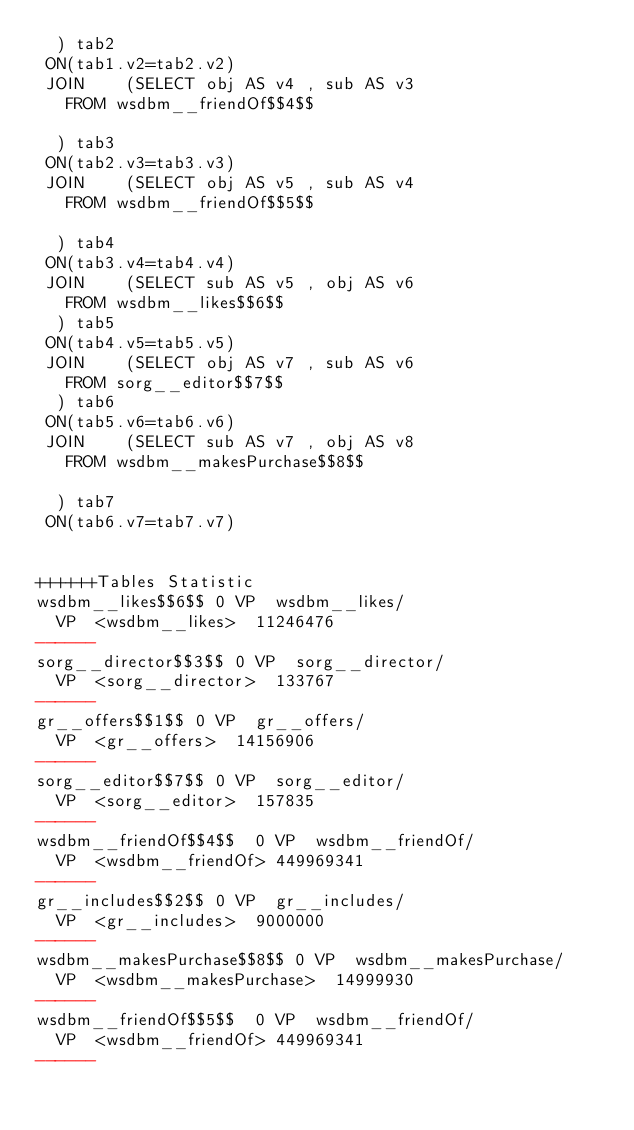Convert code to text. <code><loc_0><loc_0><loc_500><loc_500><_SQL_>	) tab2
 ON(tab1.v2=tab2.v2)
 JOIN    (SELECT obj AS v4 , sub AS v3 
	 FROM wsdbm__friendOf$$4$$
	
	) tab3
 ON(tab2.v3=tab3.v3)
 JOIN    (SELECT obj AS v5 , sub AS v4 
	 FROM wsdbm__friendOf$$5$$
	
	) tab4
 ON(tab3.v4=tab4.v4)
 JOIN    (SELECT sub AS v5 , obj AS v6 
	 FROM wsdbm__likes$$6$$
	) tab5
 ON(tab4.v5=tab5.v5)
 JOIN    (SELECT obj AS v7 , sub AS v6 
	 FROM sorg__editor$$7$$
	) tab6
 ON(tab5.v6=tab6.v6)
 JOIN    (SELECT sub AS v7 , obj AS v8 
	 FROM wsdbm__makesPurchase$$8$$
	
	) tab7
 ON(tab6.v7=tab7.v7)


++++++Tables Statistic
wsdbm__likes$$6$$	0	VP	wsdbm__likes/
	VP	<wsdbm__likes>	11246476
------
sorg__director$$3$$	0	VP	sorg__director/
	VP	<sorg__director>	133767
------
gr__offers$$1$$	0	VP	gr__offers/
	VP	<gr__offers>	14156906
------
sorg__editor$$7$$	0	VP	sorg__editor/
	VP	<sorg__editor>	157835
------
wsdbm__friendOf$$4$$	0	VP	wsdbm__friendOf/
	VP	<wsdbm__friendOf>	449969341
------
gr__includes$$2$$	0	VP	gr__includes/
	VP	<gr__includes>	9000000
------
wsdbm__makesPurchase$$8$$	0	VP	wsdbm__makesPurchase/
	VP	<wsdbm__makesPurchase>	14999930
------
wsdbm__friendOf$$5$$	0	VP	wsdbm__friendOf/
	VP	<wsdbm__friendOf>	449969341
------
</code> 